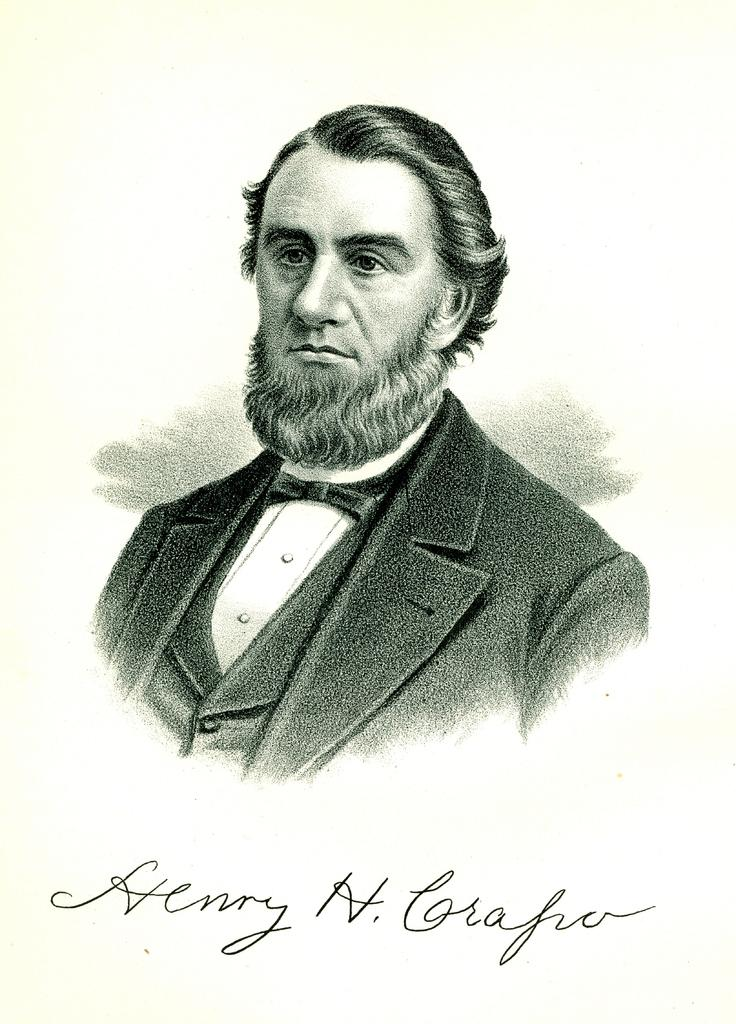What type of picture is in the image? The image contains a black and white picture of a person. Can you describe any additional elements in the image? There is text at the bottom of the image. How many pets are visible in the image? There are no pets present in the image; it contains a black and white picture of a person and text at the bottom. 